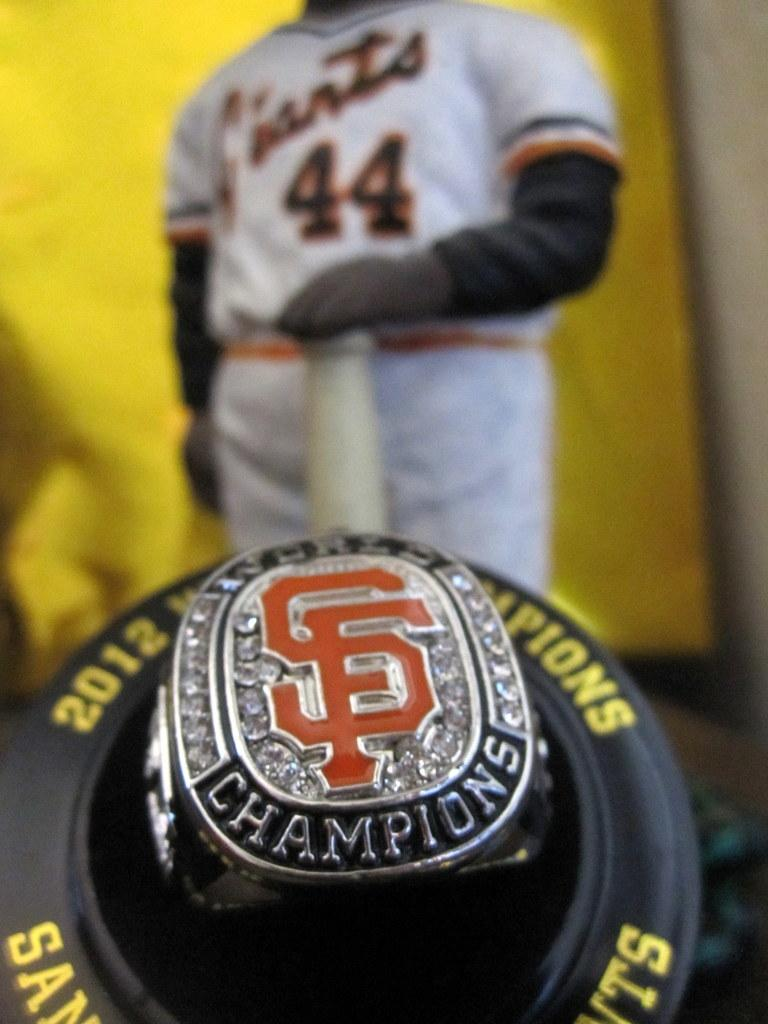<image>
Offer a succinct explanation of the picture presented. Championship ring for a baseball team in the year 2012. 